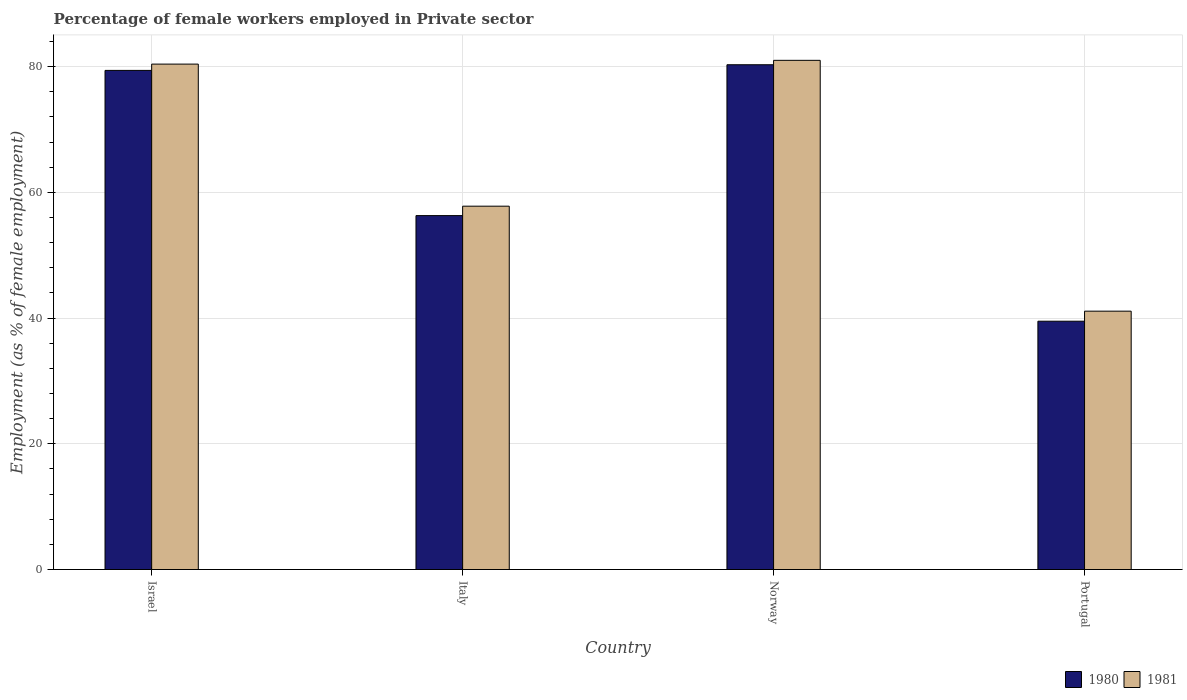How many different coloured bars are there?
Offer a very short reply. 2. How many groups of bars are there?
Ensure brevity in your answer.  4. Are the number of bars on each tick of the X-axis equal?
Your answer should be very brief. Yes. How many bars are there on the 4th tick from the left?
Make the answer very short. 2. How many bars are there on the 4th tick from the right?
Your answer should be compact. 2. What is the label of the 4th group of bars from the left?
Keep it short and to the point. Portugal. In how many cases, is the number of bars for a given country not equal to the number of legend labels?
Provide a succinct answer. 0. What is the percentage of females employed in Private sector in 1980 in Israel?
Your answer should be compact. 79.4. Across all countries, what is the maximum percentage of females employed in Private sector in 1980?
Offer a very short reply. 80.3. Across all countries, what is the minimum percentage of females employed in Private sector in 1981?
Your answer should be very brief. 41.1. In which country was the percentage of females employed in Private sector in 1981 maximum?
Keep it short and to the point. Norway. In which country was the percentage of females employed in Private sector in 1980 minimum?
Offer a terse response. Portugal. What is the total percentage of females employed in Private sector in 1980 in the graph?
Offer a very short reply. 255.5. What is the difference between the percentage of females employed in Private sector in 1980 in Norway and that in Portugal?
Offer a terse response. 40.8. What is the difference between the percentage of females employed in Private sector in 1980 in Portugal and the percentage of females employed in Private sector in 1981 in Israel?
Your answer should be compact. -40.9. What is the average percentage of females employed in Private sector in 1981 per country?
Offer a very short reply. 65.07. What is the difference between the percentage of females employed in Private sector of/in 1981 and percentage of females employed in Private sector of/in 1980 in Norway?
Offer a very short reply. 0.7. In how many countries, is the percentage of females employed in Private sector in 1980 greater than 40 %?
Ensure brevity in your answer.  3. What is the ratio of the percentage of females employed in Private sector in 1980 in Norway to that in Portugal?
Offer a terse response. 2.03. What is the difference between the highest and the second highest percentage of females employed in Private sector in 1981?
Give a very brief answer. -0.6. What is the difference between the highest and the lowest percentage of females employed in Private sector in 1981?
Offer a terse response. 39.9. In how many countries, is the percentage of females employed in Private sector in 1981 greater than the average percentage of females employed in Private sector in 1981 taken over all countries?
Your answer should be very brief. 2. Is the sum of the percentage of females employed in Private sector in 1981 in Israel and Italy greater than the maximum percentage of females employed in Private sector in 1980 across all countries?
Offer a very short reply. Yes. What does the 2nd bar from the left in Israel represents?
Your response must be concise. 1981. How many bars are there?
Provide a succinct answer. 8. Are all the bars in the graph horizontal?
Your answer should be very brief. No. What is the difference between two consecutive major ticks on the Y-axis?
Offer a very short reply. 20. Does the graph contain any zero values?
Offer a terse response. No. Where does the legend appear in the graph?
Give a very brief answer. Bottom right. How are the legend labels stacked?
Make the answer very short. Horizontal. What is the title of the graph?
Your response must be concise. Percentage of female workers employed in Private sector. What is the label or title of the Y-axis?
Keep it short and to the point. Employment (as % of female employment). What is the Employment (as % of female employment) of 1980 in Israel?
Ensure brevity in your answer.  79.4. What is the Employment (as % of female employment) of 1981 in Israel?
Offer a very short reply. 80.4. What is the Employment (as % of female employment) of 1980 in Italy?
Ensure brevity in your answer.  56.3. What is the Employment (as % of female employment) in 1981 in Italy?
Provide a short and direct response. 57.8. What is the Employment (as % of female employment) of 1980 in Norway?
Offer a very short reply. 80.3. What is the Employment (as % of female employment) in 1981 in Norway?
Offer a very short reply. 81. What is the Employment (as % of female employment) in 1980 in Portugal?
Offer a terse response. 39.5. What is the Employment (as % of female employment) of 1981 in Portugal?
Your answer should be compact. 41.1. Across all countries, what is the maximum Employment (as % of female employment) in 1980?
Ensure brevity in your answer.  80.3. Across all countries, what is the maximum Employment (as % of female employment) of 1981?
Provide a succinct answer. 81. Across all countries, what is the minimum Employment (as % of female employment) in 1980?
Ensure brevity in your answer.  39.5. Across all countries, what is the minimum Employment (as % of female employment) in 1981?
Offer a very short reply. 41.1. What is the total Employment (as % of female employment) in 1980 in the graph?
Provide a succinct answer. 255.5. What is the total Employment (as % of female employment) in 1981 in the graph?
Offer a terse response. 260.3. What is the difference between the Employment (as % of female employment) of 1980 in Israel and that in Italy?
Ensure brevity in your answer.  23.1. What is the difference between the Employment (as % of female employment) in 1981 in Israel and that in Italy?
Your answer should be very brief. 22.6. What is the difference between the Employment (as % of female employment) of 1980 in Israel and that in Norway?
Offer a terse response. -0.9. What is the difference between the Employment (as % of female employment) in 1980 in Israel and that in Portugal?
Your answer should be compact. 39.9. What is the difference between the Employment (as % of female employment) of 1981 in Israel and that in Portugal?
Provide a succinct answer. 39.3. What is the difference between the Employment (as % of female employment) of 1980 in Italy and that in Norway?
Offer a terse response. -24. What is the difference between the Employment (as % of female employment) of 1981 in Italy and that in Norway?
Give a very brief answer. -23.2. What is the difference between the Employment (as % of female employment) of 1980 in Norway and that in Portugal?
Provide a short and direct response. 40.8. What is the difference between the Employment (as % of female employment) in 1981 in Norway and that in Portugal?
Keep it short and to the point. 39.9. What is the difference between the Employment (as % of female employment) in 1980 in Israel and the Employment (as % of female employment) in 1981 in Italy?
Provide a succinct answer. 21.6. What is the difference between the Employment (as % of female employment) of 1980 in Israel and the Employment (as % of female employment) of 1981 in Norway?
Offer a very short reply. -1.6. What is the difference between the Employment (as % of female employment) of 1980 in Israel and the Employment (as % of female employment) of 1981 in Portugal?
Ensure brevity in your answer.  38.3. What is the difference between the Employment (as % of female employment) of 1980 in Italy and the Employment (as % of female employment) of 1981 in Norway?
Offer a very short reply. -24.7. What is the difference between the Employment (as % of female employment) of 1980 in Italy and the Employment (as % of female employment) of 1981 in Portugal?
Provide a short and direct response. 15.2. What is the difference between the Employment (as % of female employment) of 1980 in Norway and the Employment (as % of female employment) of 1981 in Portugal?
Make the answer very short. 39.2. What is the average Employment (as % of female employment) of 1980 per country?
Give a very brief answer. 63.88. What is the average Employment (as % of female employment) in 1981 per country?
Give a very brief answer. 65.08. What is the difference between the Employment (as % of female employment) of 1980 and Employment (as % of female employment) of 1981 in Israel?
Offer a very short reply. -1. What is the difference between the Employment (as % of female employment) of 1980 and Employment (as % of female employment) of 1981 in Italy?
Your answer should be compact. -1.5. What is the ratio of the Employment (as % of female employment) in 1980 in Israel to that in Italy?
Your response must be concise. 1.41. What is the ratio of the Employment (as % of female employment) in 1981 in Israel to that in Italy?
Ensure brevity in your answer.  1.39. What is the ratio of the Employment (as % of female employment) in 1981 in Israel to that in Norway?
Offer a very short reply. 0.99. What is the ratio of the Employment (as % of female employment) in 1980 in Israel to that in Portugal?
Provide a succinct answer. 2.01. What is the ratio of the Employment (as % of female employment) of 1981 in Israel to that in Portugal?
Keep it short and to the point. 1.96. What is the ratio of the Employment (as % of female employment) in 1980 in Italy to that in Norway?
Provide a short and direct response. 0.7. What is the ratio of the Employment (as % of female employment) in 1981 in Italy to that in Norway?
Keep it short and to the point. 0.71. What is the ratio of the Employment (as % of female employment) of 1980 in Italy to that in Portugal?
Your answer should be compact. 1.43. What is the ratio of the Employment (as % of female employment) in 1981 in Italy to that in Portugal?
Offer a very short reply. 1.41. What is the ratio of the Employment (as % of female employment) of 1980 in Norway to that in Portugal?
Offer a terse response. 2.03. What is the ratio of the Employment (as % of female employment) of 1981 in Norway to that in Portugal?
Your answer should be compact. 1.97. What is the difference between the highest and the second highest Employment (as % of female employment) of 1980?
Ensure brevity in your answer.  0.9. What is the difference between the highest and the lowest Employment (as % of female employment) of 1980?
Keep it short and to the point. 40.8. What is the difference between the highest and the lowest Employment (as % of female employment) in 1981?
Ensure brevity in your answer.  39.9. 